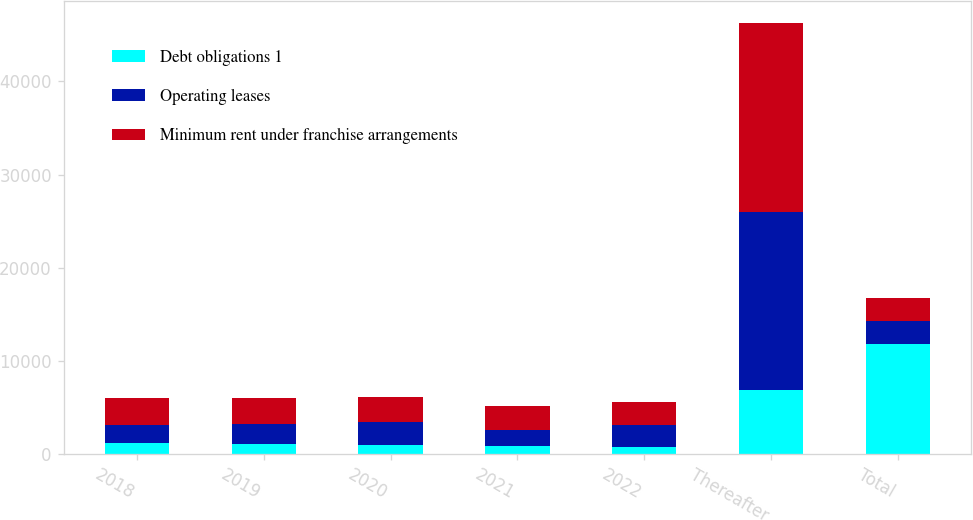<chart> <loc_0><loc_0><loc_500><loc_500><stacked_bar_chart><ecel><fcel>2018<fcel>2019<fcel>2020<fcel>2021<fcel>2022<fcel>Thereafter<fcel>Total<nl><fcel>Debt obligations 1<fcel>1152<fcel>1087<fcel>997<fcel>904<fcel>805<fcel>6912<fcel>11857<nl><fcel>Operating leases<fcel>2025<fcel>2121<fcel>2432<fcel>1717<fcel>2311<fcel>19057<fcel>2432<nl><fcel>Minimum rent under franchise arrangements<fcel>2893<fcel>2813<fcel>2707<fcel>2577<fcel>2441<fcel>20330<fcel>2432<nl></chart> 